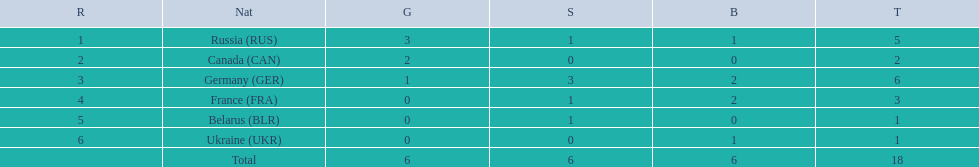Which countries competed in the 1995 biathlon? Russia (RUS), Canada (CAN), Germany (GER), France (FRA), Belarus (BLR), Ukraine (UKR). How many medals in total did they win? 5, 2, 6, 3, 1, 1. And which country had the most? Germany (GER). 